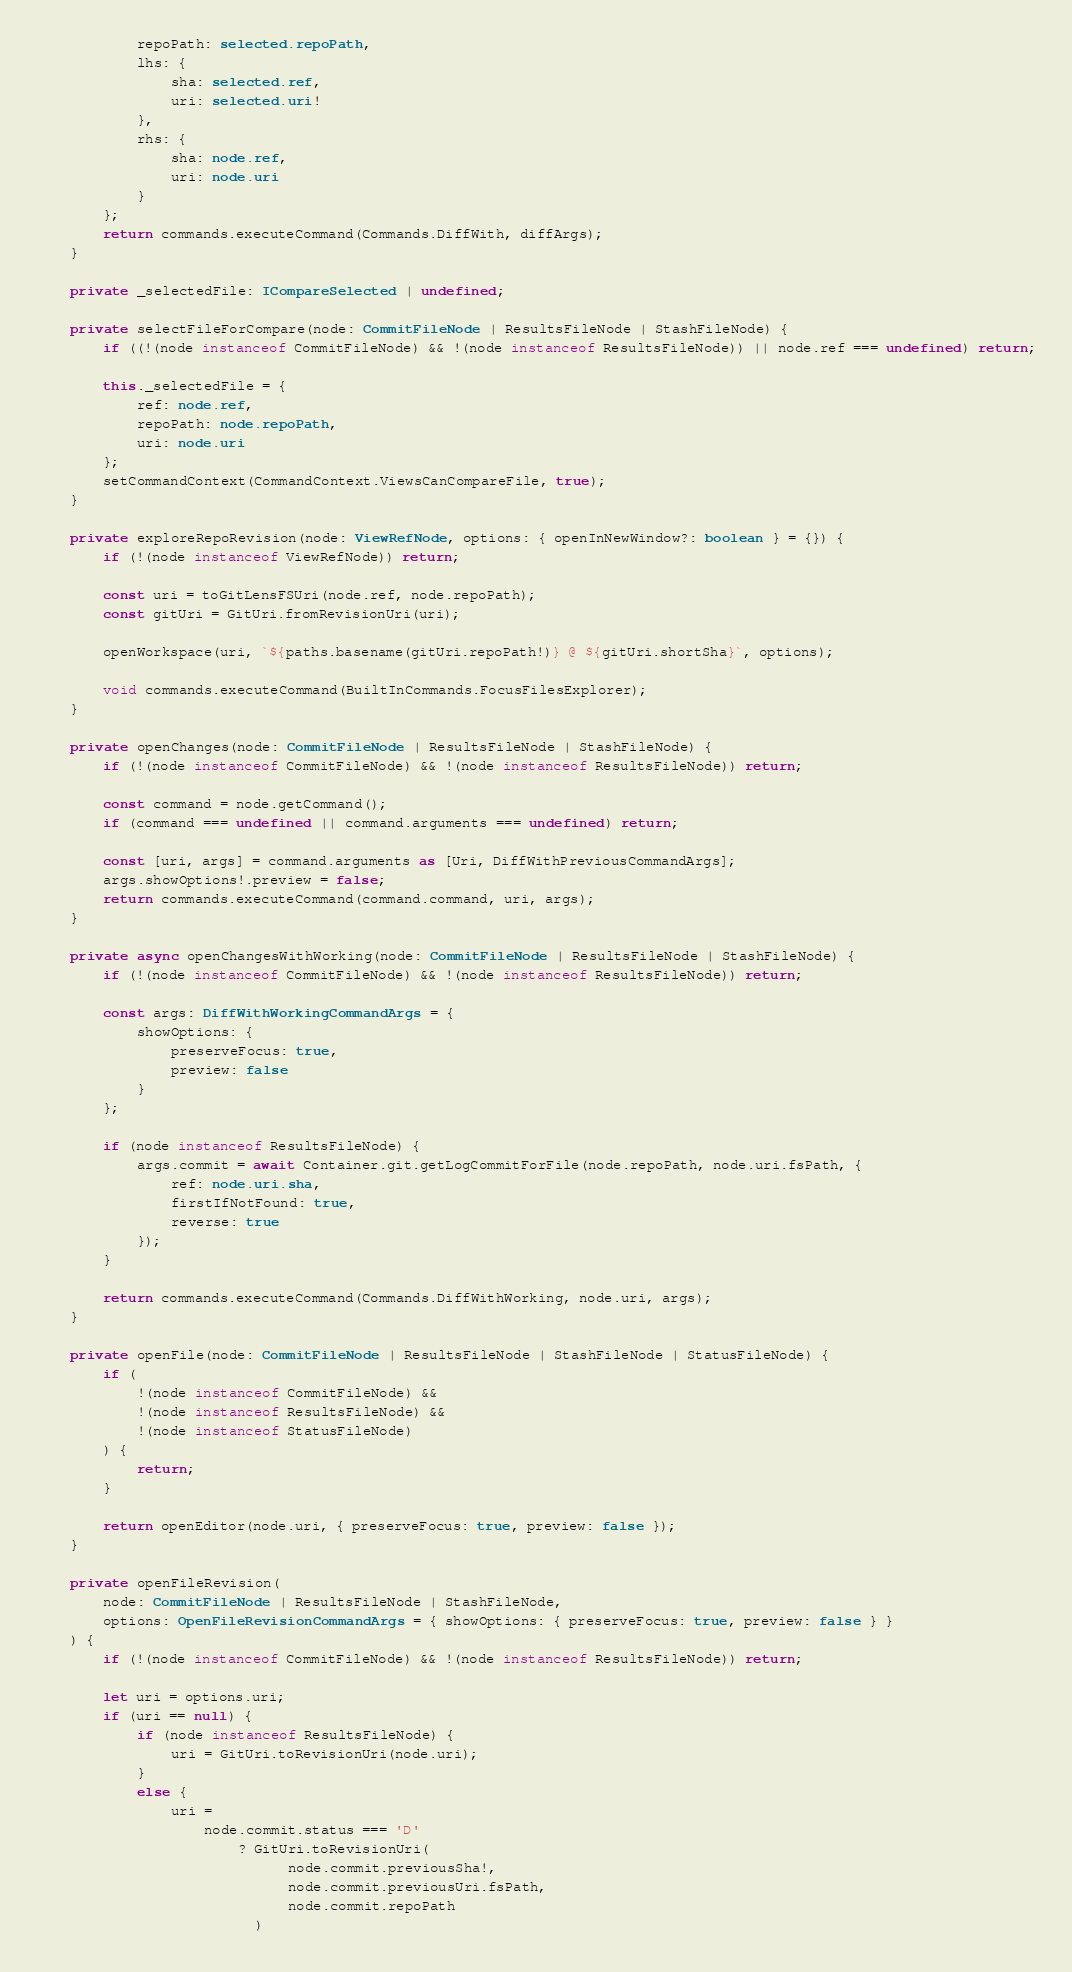Convert code to text. <code><loc_0><loc_0><loc_500><loc_500><_TypeScript_>            repoPath: selected.repoPath,
            lhs: {
                sha: selected.ref,
                uri: selected.uri!
            },
            rhs: {
                sha: node.ref,
                uri: node.uri
            }
        };
        return commands.executeCommand(Commands.DiffWith, diffArgs);
    }

    private _selectedFile: ICompareSelected | undefined;

    private selectFileForCompare(node: CommitFileNode | ResultsFileNode | StashFileNode) {
        if ((!(node instanceof CommitFileNode) && !(node instanceof ResultsFileNode)) || node.ref === undefined) return;

        this._selectedFile = {
            ref: node.ref,
            repoPath: node.repoPath,
            uri: node.uri
        };
        setCommandContext(CommandContext.ViewsCanCompareFile, true);
    }

    private exploreRepoRevision(node: ViewRefNode, options: { openInNewWindow?: boolean } = {}) {
        if (!(node instanceof ViewRefNode)) return;

        const uri = toGitLensFSUri(node.ref, node.repoPath);
        const gitUri = GitUri.fromRevisionUri(uri);

        openWorkspace(uri, `${paths.basename(gitUri.repoPath!)} @ ${gitUri.shortSha}`, options);

        void commands.executeCommand(BuiltInCommands.FocusFilesExplorer);
    }

    private openChanges(node: CommitFileNode | ResultsFileNode | StashFileNode) {
        if (!(node instanceof CommitFileNode) && !(node instanceof ResultsFileNode)) return;

        const command = node.getCommand();
        if (command === undefined || command.arguments === undefined) return;

        const [uri, args] = command.arguments as [Uri, DiffWithPreviousCommandArgs];
        args.showOptions!.preview = false;
        return commands.executeCommand(command.command, uri, args);
    }

    private async openChangesWithWorking(node: CommitFileNode | ResultsFileNode | StashFileNode) {
        if (!(node instanceof CommitFileNode) && !(node instanceof ResultsFileNode)) return;

        const args: DiffWithWorkingCommandArgs = {
            showOptions: {
                preserveFocus: true,
                preview: false
            }
        };

        if (node instanceof ResultsFileNode) {
            args.commit = await Container.git.getLogCommitForFile(node.repoPath, node.uri.fsPath, {
                ref: node.uri.sha,
                firstIfNotFound: true,
                reverse: true
            });
        }

        return commands.executeCommand(Commands.DiffWithWorking, node.uri, args);
    }

    private openFile(node: CommitFileNode | ResultsFileNode | StashFileNode | StatusFileNode) {
        if (
            !(node instanceof CommitFileNode) &&
            !(node instanceof ResultsFileNode) &&
            !(node instanceof StatusFileNode)
        ) {
            return;
        }

        return openEditor(node.uri, { preserveFocus: true, preview: false });
    }

    private openFileRevision(
        node: CommitFileNode | ResultsFileNode | StashFileNode,
        options: OpenFileRevisionCommandArgs = { showOptions: { preserveFocus: true, preview: false } }
    ) {
        if (!(node instanceof CommitFileNode) && !(node instanceof ResultsFileNode)) return;

        let uri = options.uri;
        if (uri == null) {
            if (node instanceof ResultsFileNode) {
                uri = GitUri.toRevisionUri(node.uri);
            }
            else {
                uri =
                    node.commit.status === 'D'
                        ? GitUri.toRevisionUri(
                              node.commit.previousSha!,
                              node.commit.previousUri.fsPath,
                              node.commit.repoPath
                          )</code> 